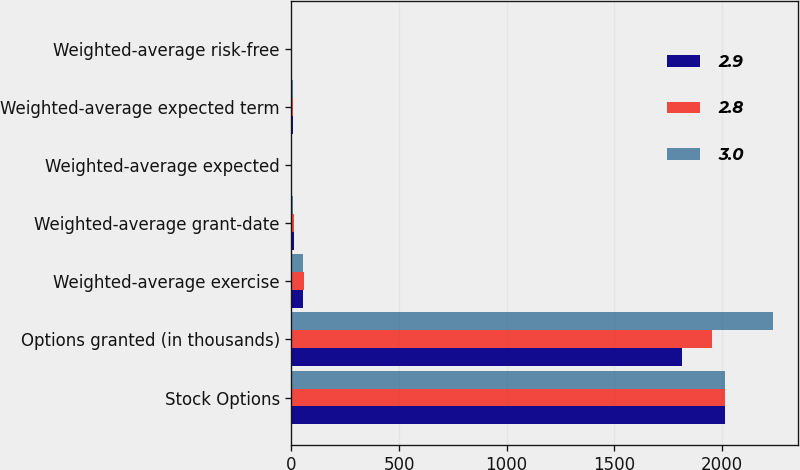Convert chart to OTSL. <chart><loc_0><loc_0><loc_500><loc_500><stacked_bar_chart><ecel><fcel>Stock Options<fcel>Options granted (in thousands)<fcel>Weighted-average exercise<fcel>Weighted-average grant-date<fcel>Weighted-average expected<fcel>Weighted-average expected term<fcel>Weighted-average risk-free<nl><fcel>2.9<fcel>2016<fcel>1814<fcel>55.19<fcel>12.67<fcel>3<fcel>5.1<fcel>1.4<nl><fcel>2.8<fcel>2015<fcel>1954<fcel>57.2<fcel>10.38<fcel>2.8<fcel>5.3<fcel>1.6<nl><fcel>3<fcel>2014<fcel>2240<fcel>51.52<fcel>8.74<fcel>2.9<fcel>5.3<fcel>1.7<nl></chart> 